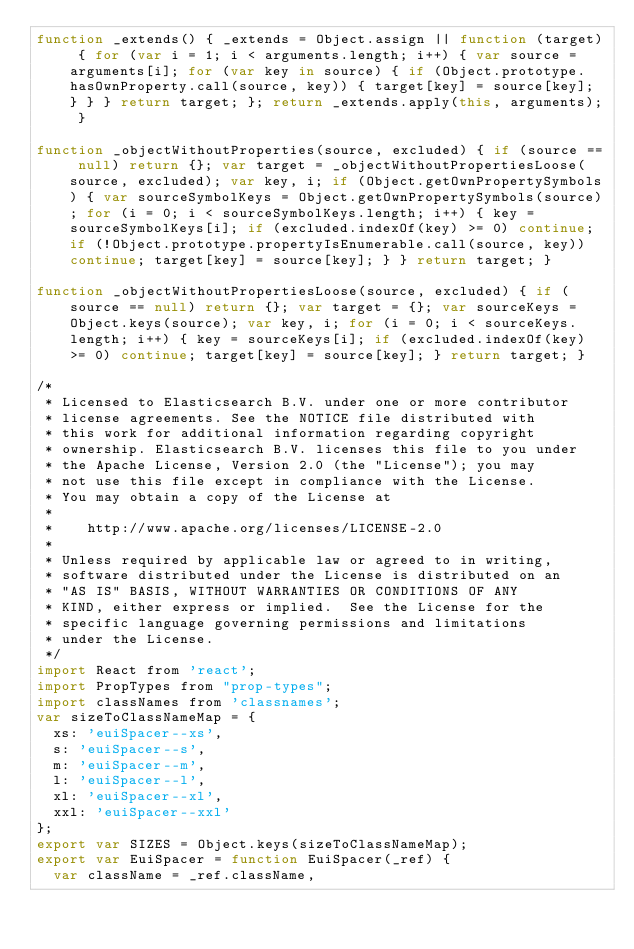Convert code to text. <code><loc_0><loc_0><loc_500><loc_500><_JavaScript_>function _extends() { _extends = Object.assign || function (target) { for (var i = 1; i < arguments.length; i++) { var source = arguments[i]; for (var key in source) { if (Object.prototype.hasOwnProperty.call(source, key)) { target[key] = source[key]; } } } return target; }; return _extends.apply(this, arguments); }

function _objectWithoutProperties(source, excluded) { if (source == null) return {}; var target = _objectWithoutPropertiesLoose(source, excluded); var key, i; if (Object.getOwnPropertySymbols) { var sourceSymbolKeys = Object.getOwnPropertySymbols(source); for (i = 0; i < sourceSymbolKeys.length; i++) { key = sourceSymbolKeys[i]; if (excluded.indexOf(key) >= 0) continue; if (!Object.prototype.propertyIsEnumerable.call(source, key)) continue; target[key] = source[key]; } } return target; }

function _objectWithoutPropertiesLoose(source, excluded) { if (source == null) return {}; var target = {}; var sourceKeys = Object.keys(source); var key, i; for (i = 0; i < sourceKeys.length; i++) { key = sourceKeys[i]; if (excluded.indexOf(key) >= 0) continue; target[key] = source[key]; } return target; }

/*
 * Licensed to Elasticsearch B.V. under one or more contributor
 * license agreements. See the NOTICE file distributed with
 * this work for additional information regarding copyright
 * ownership. Elasticsearch B.V. licenses this file to you under
 * the Apache License, Version 2.0 (the "License"); you may
 * not use this file except in compliance with the License.
 * You may obtain a copy of the License at
 *
 *    http://www.apache.org/licenses/LICENSE-2.0
 *
 * Unless required by applicable law or agreed to in writing,
 * software distributed under the License is distributed on an
 * "AS IS" BASIS, WITHOUT WARRANTIES OR CONDITIONS OF ANY
 * KIND, either express or implied.  See the License for the
 * specific language governing permissions and limitations
 * under the License.
 */
import React from 'react';
import PropTypes from "prop-types";
import classNames from 'classnames';
var sizeToClassNameMap = {
  xs: 'euiSpacer--xs',
  s: 'euiSpacer--s',
  m: 'euiSpacer--m',
  l: 'euiSpacer--l',
  xl: 'euiSpacer--xl',
  xxl: 'euiSpacer--xxl'
};
export var SIZES = Object.keys(sizeToClassNameMap);
export var EuiSpacer = function EuiSpacer(_ref) {
  var className = _ref.className,</code> 